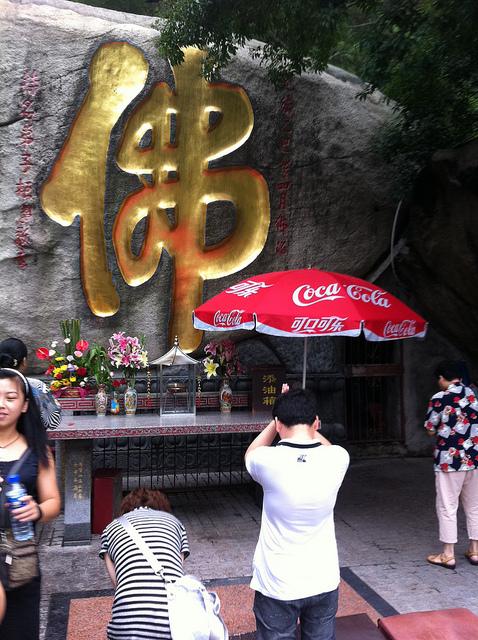Where is this place?
Keep it brief. China. What does the golden character on the wall mean?
Quick response, please. Peace. Why are these people bowing their heads?
Keep it brief. Worship. 